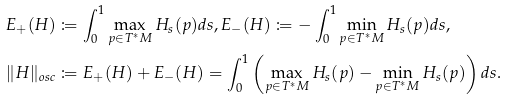<formula> <loc_0><loc_0><loc_500><loc_500>E _ { + } ( H ) & \coloneqq \int _ { 0 } ^ { 1 } \max _ { p \in T ^ { * } M } H _ { s } ( p ) d s , E _ { - } ( H ) \coloneqq - \int _ { 0 } ^ { 1 } \min _ { p \in T ^ { * } M } H _ { s } ( p ) d s , \\ \| H \| _ { o s c } & \coloneqq E _ { + } ( H ) + E _ { - } ( H ) = \int _ { 0 } ^ { 1 } \left ( \max _ { p \in T ^ { * } M } H _ { s } ( p ) - \min _ { p \in T ^ { * } M } H _ { s } ( p ) \right ) d s .</formula> 